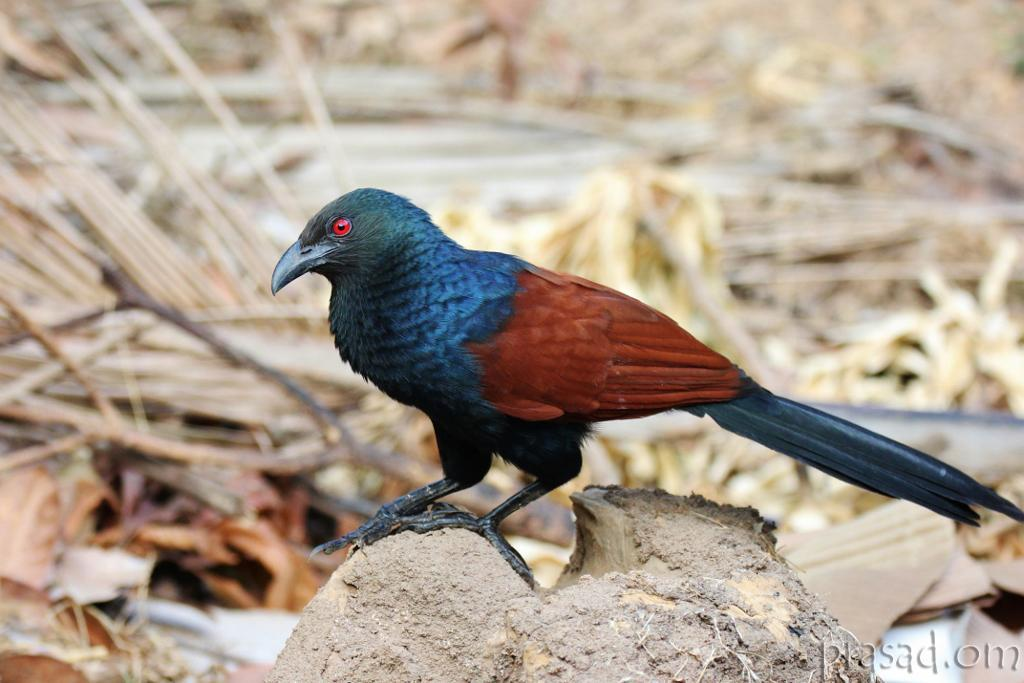What type of animal is present in the image? There is a bird in the image. Where is the bird located? The bird is on a trunk. What can be seen in the background of the image? There are twigs in the background of the image. Is there any text visible in the image? Yes, there is some text visible in the image. Can you tell me how many loaves of bread are being controlled by the bird in the image? There are no loaves of bread or any indication of control present in the image; it features a bird on a trunk with twigs in the background and some text visible. 